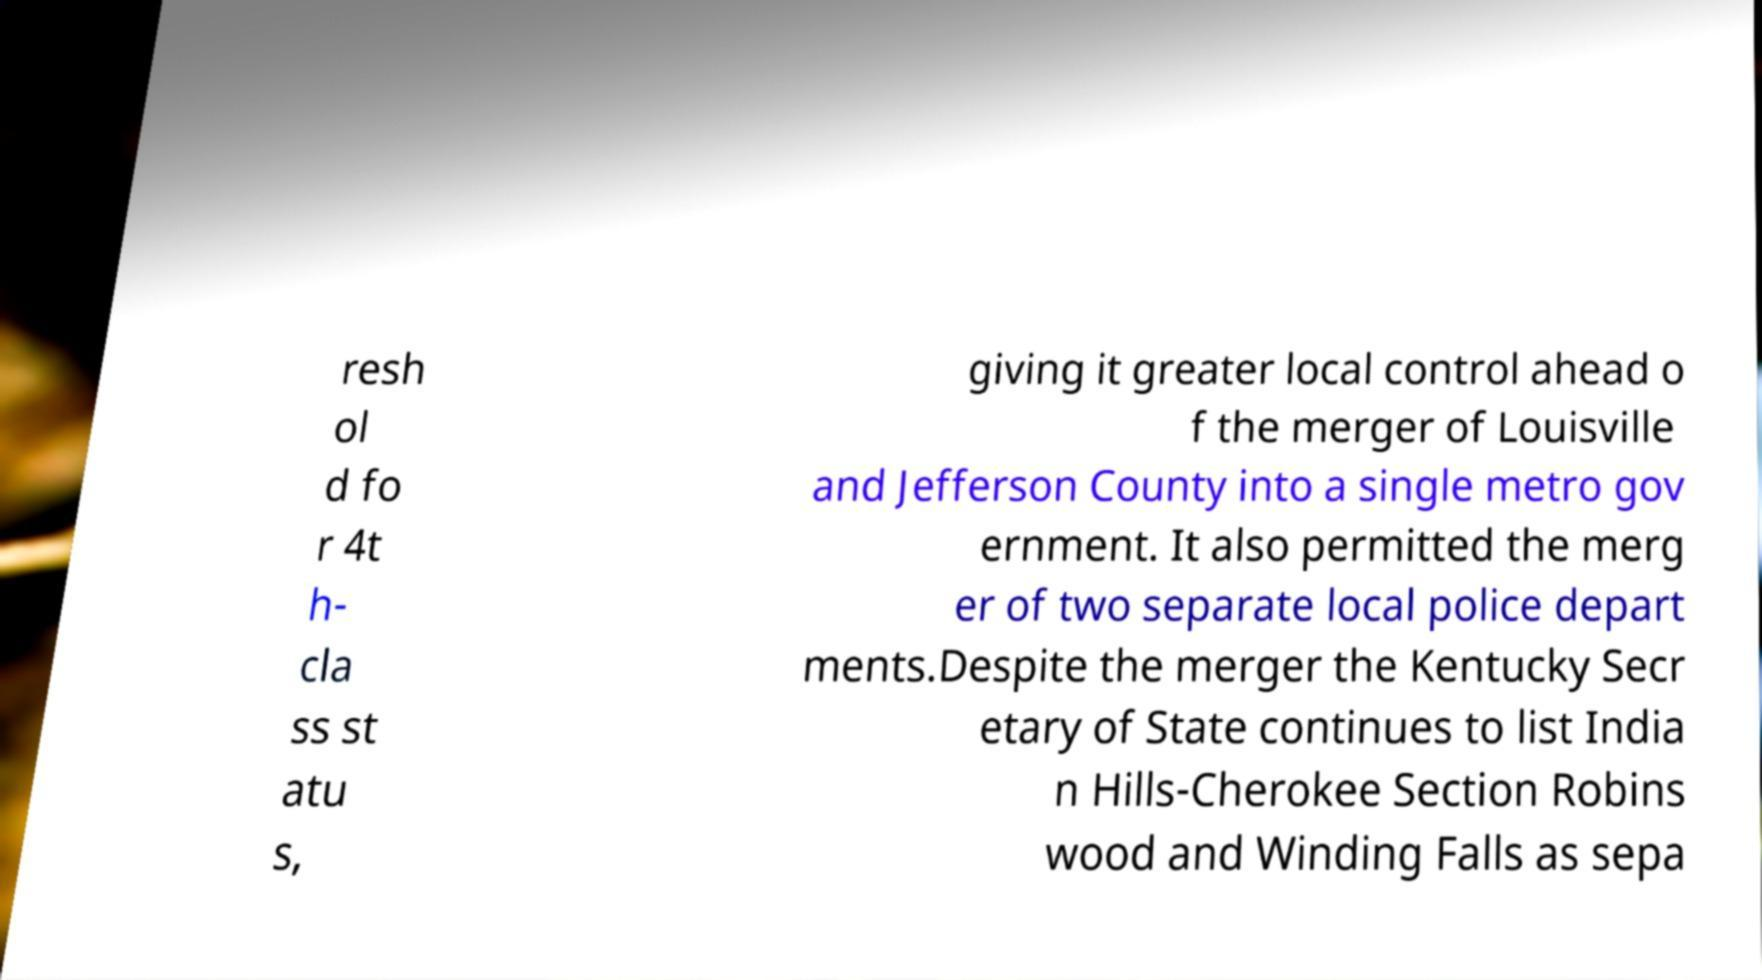What messages or text are displayed in this image? I need them in a readable, typed format. resh ol d fo r 4t h- cla ss st atu s, giving it greater local control ahead o f the merger of Louisville and Jefferson County into a single metro gov ernment. It also permitted the merg er of two separate local police depart ments.Despite the merger the Kentucky Secr etary of State continues to list India n Hills-Cherokee Section Robins wood and Winding Falls as sepa 